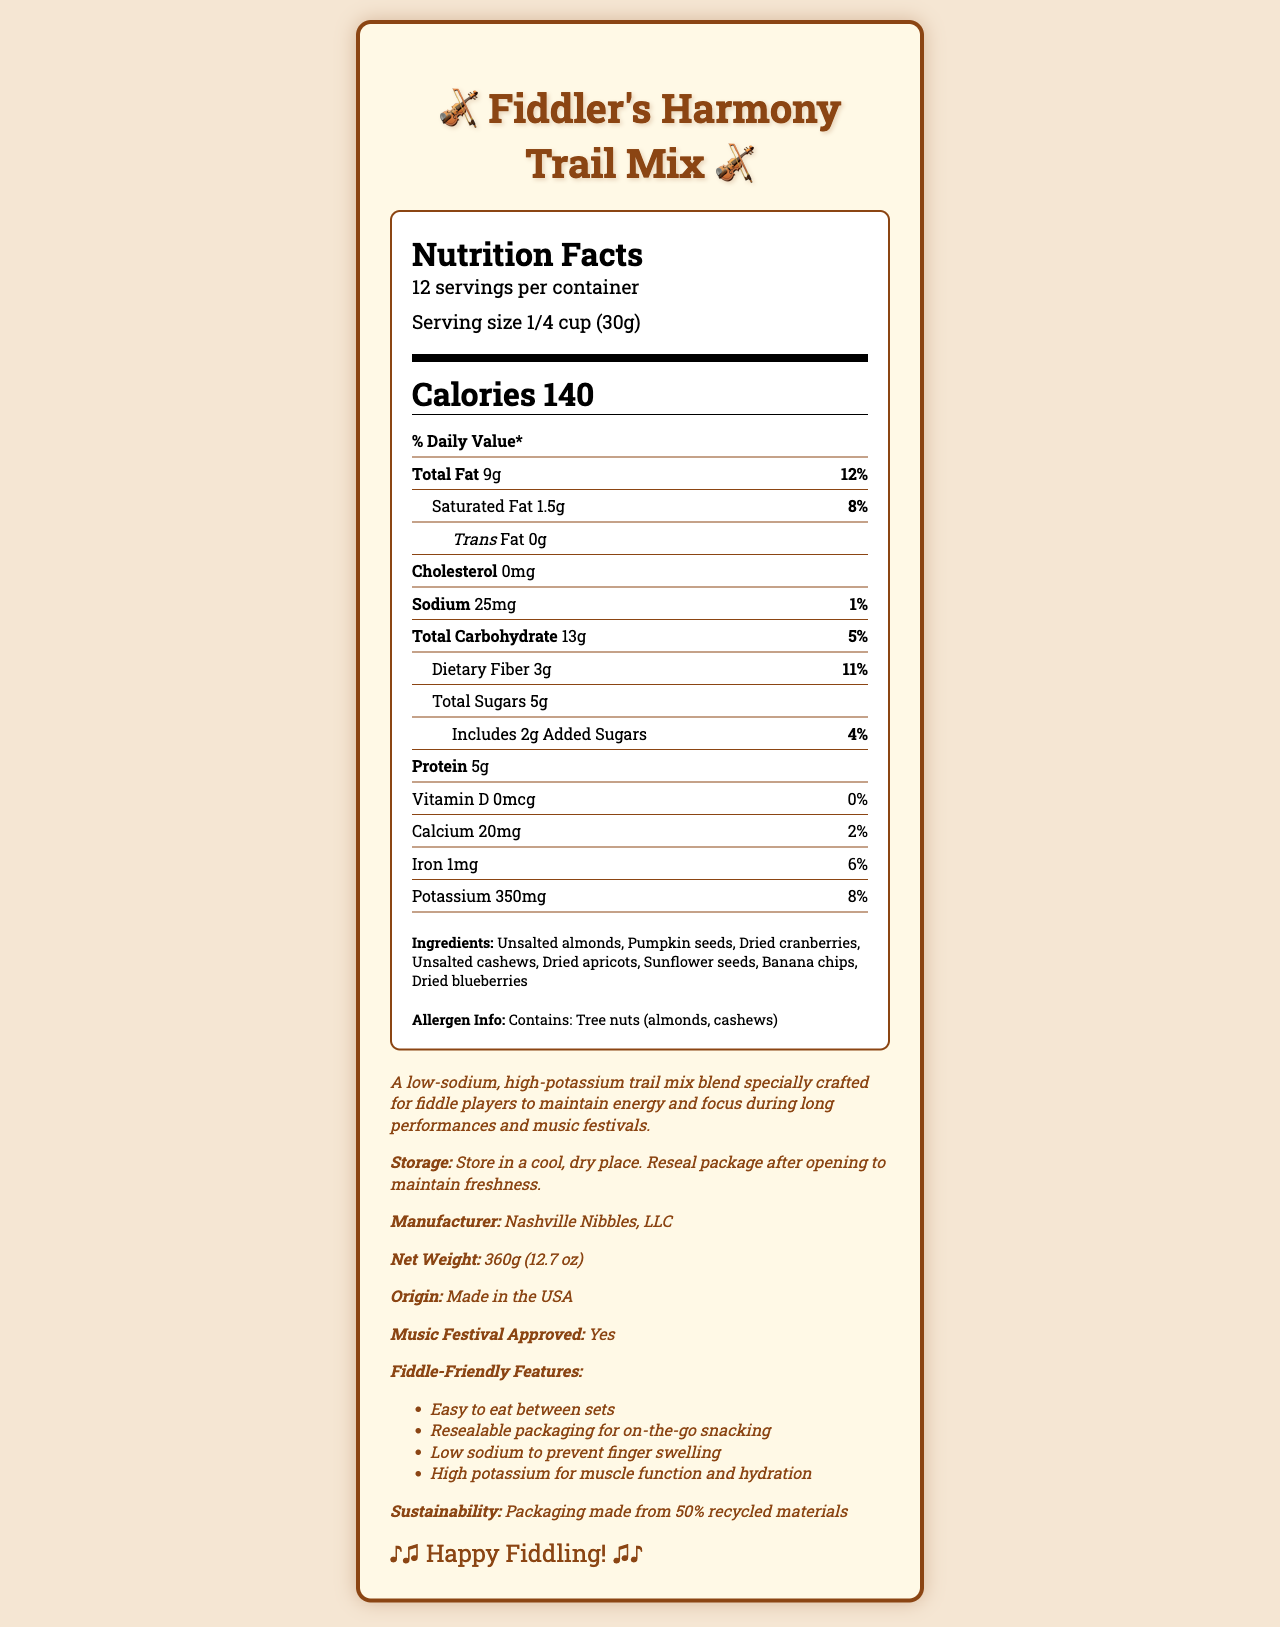what is the serving size of Fiddler's Harmony Trail Mix? The serving size is listed in the Nutrition Facts section of the label as "1/4 cup (30g)".
Answer: 1/4 cup (30g) how many servings are there per container? This information is presented at the top of the Nutrition Facts section where it states "12 servings per container".
Answer: 12 how much potassium is in one serving of Fiddler's Harmony Trail Mix? The amount of potassium is specified in the nutrient breakdown under the "Potassium" row as "350mg".
Answer: 350mg what is the main source of protein in this trail mix? These items are listed in the ingredients section and are known to be good sources of protein.
Answer: Ingredients like unsalted almonds, pumpkin seeds, unsalted cashews, and sunflower seeds what are the fiddle-friendly features of this trail mix? These features are listed in the "Fiddle-Friendly Features" section at the bottom of the document.
Answer: Easy to eat between sets, Resealable packaging for on-the-go snacking, Low sodium to prevent finger swelling, High potassium for muscle function and hydration how much total carbohydrate is in one serving? The amount of total carbohydrates is listed under the "Total Carbohydrate" row as "13g".
Answer: 13g which of the following ingredients is not included in the trail mix? (A) Dried cranberries (B) Dried apricots (C) Peanuts (D) Banana chips Peanuts are not listed in the ingredients.
Answer: C what is the serving size in grams? (1) 45g (2) 15g (3) 30g (4) 60g The serving size is "1/4 cup" which is equivalent to "30g" as stated in the serving information.
Answer: 3 does Fiddler's Harmony Trail Mix contain any cholesterol? The document states "Cholesterol: 0mg", indicating no cholesterol content.
Answer: No summarize the content and purpose of this document. This document lists the nutritional values, ingredients, allergen information, and describes the purpose and special features of the trail mix targeting fiddle players.
Answer: The document provides detailed nutritional information, ingredient list, and additional features of "Fiddler's Harmony Trail Mix". The trail mix is designed to be low-sodium and high-potassium, making it suitable for fiddle players to consume during long performances. It also highlights the fiddle-friendly features such as being easy to eat between sets and having resealable packaging. what is the exact amount of added sugars in the trail mix? The added sugars are explicitly listed as "Includes 2g Added Sugars" in the nutrient breakdown.
Answer: 2g who is the manufacturer of Fiddler's Harmony Trail Mix? This information is provided at the bottom of the document in the product information section.
Answer: Nashville Nibbles, LLC does this product contain any vitamin D? The document lists "Vitamin D: 0mcg" and "0%" indicating there is no vitamin D in the product.
Answer: No what allergens are present in Fiddler's Harmony Trail Mix? The allergen information section states that the product contains tree nuts, specifically almonds and cashews.
Answer: Tree nuts (almonds, cashews) what is the main idea of this document? The primary focus of the document is to describe the nutritional benefits, special features, and intended audience for "Fiddler's Harmony Trail Mix".
Answer: The document provides comprehensive nutritional details and special features of a low-sodium, high-potassium trail mix designed for fiddle players, emphasizing its benefits for maintaining energy and hydration during performances. how is the sustainability information of the packaging described? The sustainability information clearly states that the packaging is made from 50% recycled materials.
Answer: Packaging made from 50% recycled materials what is the cost of Fiddler's Harmony Trail Mix? The document does not provide any information regarding the price of the trail mix.
Answer: Not enough information 